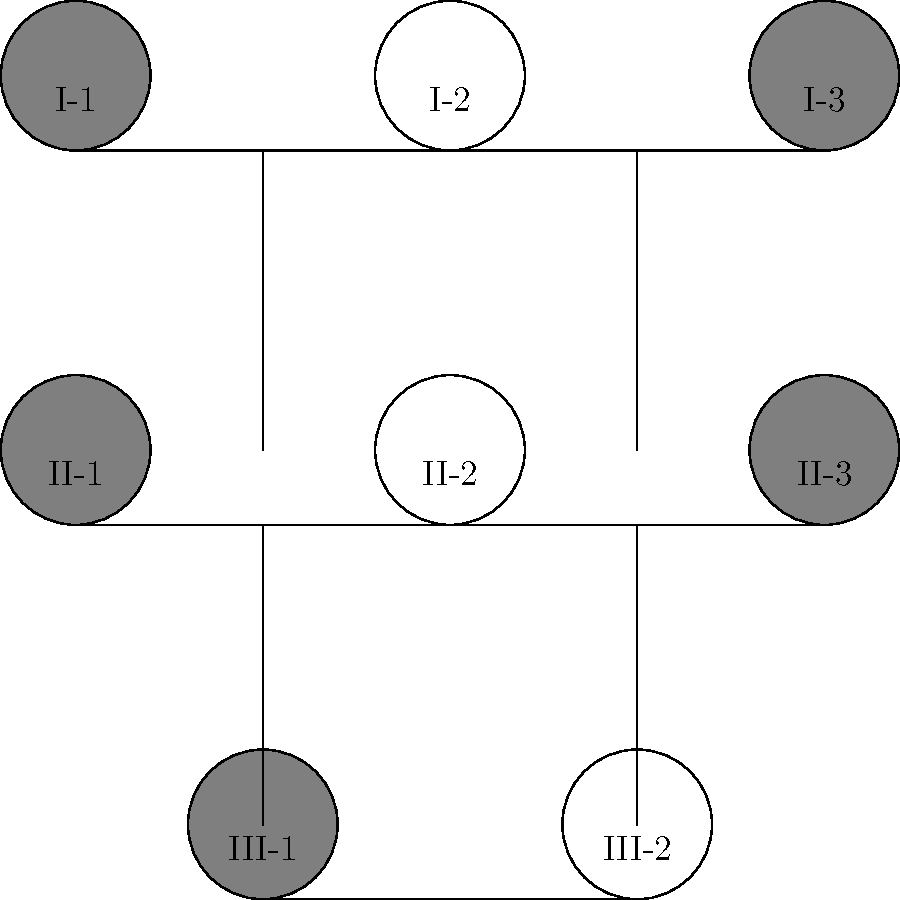Analyze the pedigree chart above, which represents the inheritance pattern of a rare genetic disorder. Affected individuals are shaded, and unaffected individuals are unshaded. Based on this information, determine the most likely mode of inheritance for this disorder and calculate the probability that individual III-2 is affected, given that both parents (II-2 and II-3) are unaffected carriers. To solve this problem, let's follow these steps:

1. Identify the inheritance pattern:
   - The disorder appears in both males and females.
   - Affected individuals have unaffected parents.
   - The trait appears to skip generations.
   - Unaffected parents can have affected children.

   These characteristics are consistent with an autosomal recessive inheritance pattern.

2. Confirm autosomal recessive inheritance:
   - In autosomal recessive disorders, both parents must be carriers (heterozygous) to produce an affected child.
   - This is consistent with II-2 and II-3 being unaffected but having an affected child (III-1).

3. Determine the genotypes:
   - Let 'a' represent the recessive allele causing the disorder, and 'A' the normal dominant allele.
   - Affected individuals are 'aa'.
   - Unaffected carriers are 'Aa'.
   - II-2 and II-3 must be 'Aa' to have an affected child.

4. Calculate the probability of III-2 being affected:
   - For III-2 to be affected, they must inherit the 'a' allele from both parents.
   - The probability of inheriting 'a' from each parent is 1/2.
   - The probability of inheriting 'a' from both parents is:
     $P(\text{aa}) = \frac{1}{2} \times \frac{1}{2} = \frac{1}{4} = 0.25$ or 25%

Therefore, the probability that individual III-2 is affected is 25%.
Answer: Autosomal recessive; 25% 